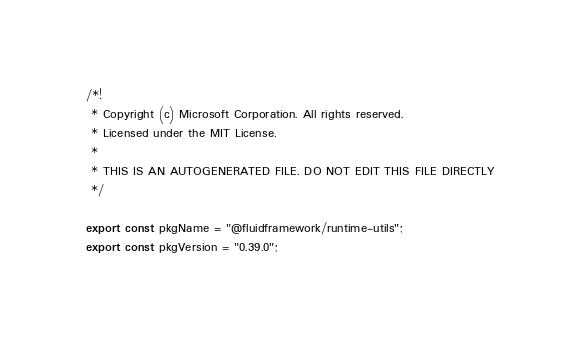<code> <loc_0><loc_0><loc_500><loc_500><_TypeScript_>/*!
 * Copyright (c) Microsoft Corporation. All rights reserved.
 * Licensed under the MIT License.
 *
 * THIS IS AN AUTOGENERATED FILE. DO NOT EDIT THIS FILE DIRECTLY
 */

export const pkgName = "@fluidframework/runtime-utils";
export const pkgVersion = "0.39.0";
</code> 